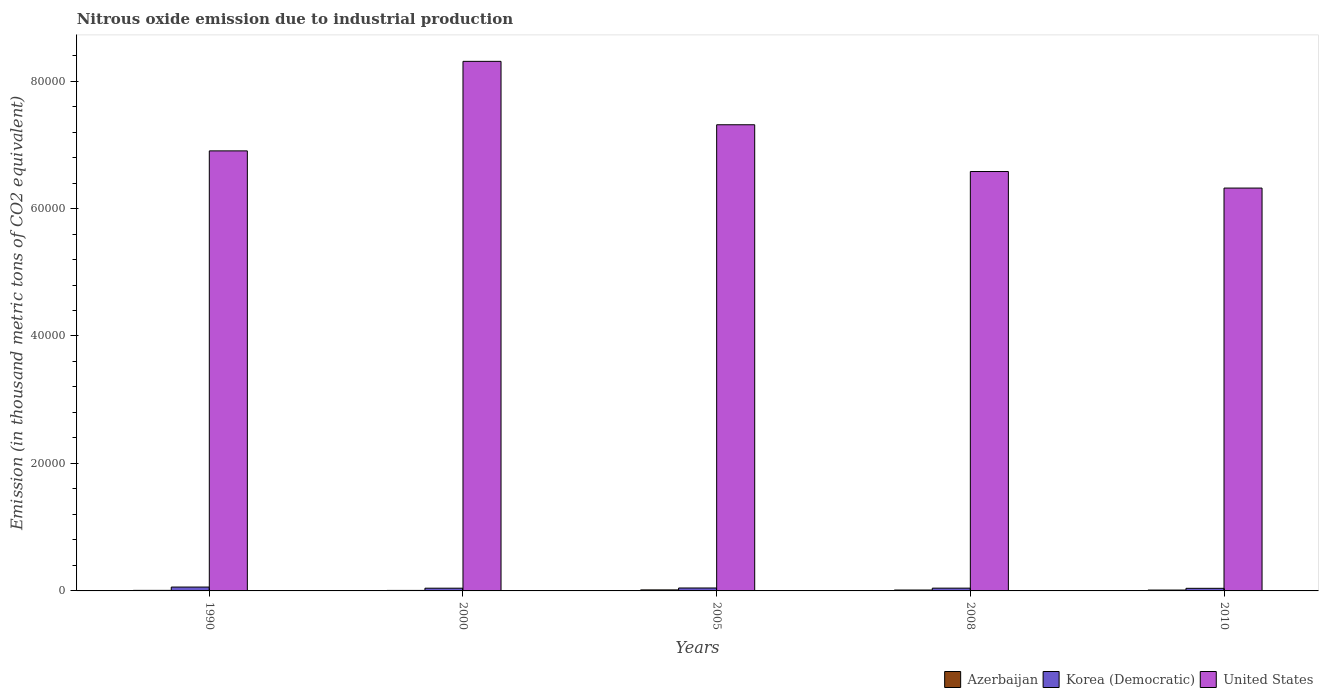How many different coloured bars are there?
Provide a succinct answer. 3. How many groups of bars are there?
Offer a terse response. 5. Are the number of bars per tick equal to the number of legend labels?
Your response must be concise. Yes. Are the number of bars on each tick of the X-axis equal?
Your response must be concise. Yes. How many bars are there on the 1st tick from the left?
Make the answer very short. 3. What is the label of the 3rd group of bars from the left?
Ensure brevity in your answer.  2005. In how many cases, is the number of bars for a given year not equal to the number of legend labels?
Give a very brief answer. 0. What is the amount of nitrous oxide emitted in Azerbaijan in 2000?
Keep it short and to the point. 79.5. Across all years, what is the maximum amount of nitrous oxide emitted in Azerbaijan?
Your answer should be very brief. 160.4. Across all years, what is the minimum amount of nitrous oxide emitted in Azerbaijan?
Offer a very short reply. 79.5. In which year was the amount of nitrous oxide emitted in Azerbaijan minimum?
Offer a terse response. 2000. What is the total amount of nitrous oxide emitted in Azerbaijan in the graph?
Keep it short and to the point. 604. What is the difference between the amount of nitrous oxide emitted in United States in 1990 and that in 2008?
Offer a very short reply. 3238.6. What is the difference between the amount of nitrous oxide emitted in Azerbaijan in 2000 and the amount of nitrous oxide emitted in Korea (Democratic) in 1990?
Provide a short and direct response. -526.1. What is the average amount of nitrous oxide emitted in Korea (Democratic) per year?
Provide a succinct answer. 467.46. In the year 2010, what is the difference between the amount of nitrous oxide emitted in Korea (Democratic) and amount of nitrous oxide emitted in Azerbaijan?
Give a very brief answer. 272.8. What is the ratio of the amount of nitrous oxide emitted in Azerbaijan in 2005 to that in 2008?
Your answer should be compact. 1.14. Is the amount of nitrous oxide emitted in United States in 1990 less than that in 2008?
Provide a succinct answer. No. Is the difference between the amount of nitrous oxide emitted in Korea (Democratic) in 2005 and 2010 greater than the difference between the amount of nitrous oxide emitted in Azerbaijan in 2005 and 2010?
Your response must be concise. Yes. What is the difference between the highest and the second highest amount of nitrous oxide emitted in United States?
Your answer should be compact. 9949.1. What is the difference between the highest and the lowest amount of nitrous oxide emitted in United States?
Provide a succinct answer. 1.99e+04. In how many years, is the amount of nitrous oxide emitted in Azerbaijan greater than the average amount of nitrous oxide emitted in Azerbaijan taken over all years?
Your response must be concise. 3. What does the 1st bar from the left in 2008 represents?
Your answer should be compact. Azerbaijan. What does the 3rd bar from the right in 1990 represents?
Keep it short and to the point. Azerbaijan. How many bars are there?
Your answer should be compact. 15. Are all the bars in the graph horizontal?
Provide a succinct answer. No. What is the difference between two consecutive major ticks on the Y-axis?
Give a very brief answer. 2.00e+04. Are the values on the major ticks of Y-axis written in scientific E-notation?
Provide a short and direct response. No. Does the graph contain grids?
Offer a terse response. No. Where does the legend appear in the graph?
Provide a succinct answer. Bottom right. How are the legend labels stacked?
Keep it short and to the point. Horizontal. What is the title of the graph?
Your answer should be very brief. Nitrous oxide emission due to industrial production. Does "Mauritania" appear as one of the legend labels in the graph?
Make the answer very short. No. What is the label or title of the Y-axis?
Your answer should be compact. Emission (in thousand metric tons of CO2 equivalent). What is the Emission (in thousand metric tons of CO2 equivalent) of Azerbaijan in 1990?
Ensure brevity in your answer.  87.4. What is the Emission (in thousand metric tons of CO2 equivalent) of Korea (Democratic) in 1990?
Provide a short and direct response. 605.6. What is the Emission (in thousand metric tons of CO2 equivalent) in United States in 1990?
Keep it short and to the point. 6.90e+04. What is the Emission (in thousand metric tons of CO2 equivalent) in Azerbaijan in 2000?
Provide a succinct answer. 79.5. What is the Emission (in thousand metric tons of CO2 equivalent) of Korea (Democratic) in 2000?
Make the answer very short. 427. What is the Emission (in thousand metric tons of CO2 equivalent) in United States in 2000?
Give a very brief answer. 8.31e+04. What is the Emission (in thousand metric tons of CO2 equivalent) of Azerbaijan in 2005?
Your answer should be very brief. 160.4. What is the Emission (in thousand metric tons of CO2 equivalent) in Korea (Democratic) in 2005?
Your answer should be very brief. 460.8. What is the Emission (in thousand metric tons of CO2 equivalent) of United States in 2005?
Offer a very short reply. 7.31e+04. What is the Emission (in thousand metric tons of CO2 equivalent) in Azerbaijan in 2008?
Your response must be concise. 141. What is the Emission (in thousand metric tons of CO2 equivalent) of Korea (Democratic) in 2008?
Make the answer very short. 435.4. What is the Emission (in thousand metric tons of CO2 equivalent) in United States in 2008?
Ensure brevity in your answer.  6.58e+04. What is the Emission (in thousand metric tons of CO2 equivalent) in Azerbaijan in 2010?
Your answer should be compact. 135.7. What is the Emission (in thousand metric tons of CO2 equivalent) of Korea (Democratic) in 2010?
Provide a short and direct response. 408.5. What is the Emission (in thousand metric tons of CO2 equivalent) of United States in 2010?
Offer a very short reply. 6.32e+04. Across all years, what is the maximum Emission (in thousand metric tons of CO2 equivalent) in Azerbaijan?
Provide a succinct answer. 160.4. Across all years, what is the maximum Emission (in thousand metric tons of CO2 equivalent) of Korea (Democratic)?
Provide a short and direct response. 605.6. Across all years, what is the maximum Emission (in thousand metric tons of CO2 equivalent) in United States?
Offer a terse response. 8.31e+04. Across all years, what is the minimum Emission (in thousand metric tons of CO2 equivalent) in Azerbaijan?
Offer a very short reply. 79.5. Across all years, what is the minimum Emission (in thousand metric tons of CO2 equivalent) in Korea (Democratic)?
Your response must be concise. 408.5. Across all years, what is the minimum Emission (in thousand metric tons of CO2 equivalent) of United States?
Offer a very short reply. 6.32e+04. What is the total Emission (in thousand metric tons of CO2 equivalent) in Azerbaijan in the graph?
Give a very brief answer. 604. What is the total Emission (in thousand metric tons of CO2 equivalent) of Korea (Democratic) in the graph?
Your response must be concise. 2337.3. What is the total Emission (in thousand metric tons of CO2 equivalent) in United States in the graph?
Your answer should be compact. 3.54e+05. What is the difference between the Emission (in thousand metric tons of CO2 equivalent) in Korea (Democratic) in 1990 and that in 2000?
Provide a succinct answer. 178.6. What is the difference between the Emission (in thousand metric tons of CO2 equivalent) in United States in 1990 and that in 2000?
Offer a very short reply. -1.40e+04. What is the difference between the Emission (in thousand metric tons of CO2 equivalent) in Azerbaijan in 1990 and that in 2005?
Your answer should be very brief. -73. What is the difference between the Emission (in thousand metric tons of CO2 equivalent) of Korea (Democratic) in 1990 and that in 2005?
Your answer should be very brief. 144.8. What is the difference between the Emission (in thousand metric tons of CO2 equivalent) in United States in 1990 and that in 2005?
Keep it short and to the point. -4098.5. What is the difference between the Emission (in thousand metric tons of CO2 equivalent) of Azerbaijan in 1990 and that in 2008?
Give a very brief answer. -53.6. What is the difference between the Emission (in thousand metric tons of CO2 equivalent) of Korea (Democratic) in 1990 and that in 2008?
Provide a succinct answer. 170.2. What is the difference between the Emission (in thousand metric tons of CO2 equivalent) in United States in 1990 and that in 2008?
Give a very brief answer. 3238.6. What is the difference between the Emission (in thousand metric tons of CO2 equivalent) in Azerbaijan in 1990 and that in 2010?
Your response must be concise. -48.3. What is the difference between the Emission (in thousand metric tons of CO2 equivalent) of Korea (Democratic) in 1990 and that in 2010?
Provide a succinct answer. 197.1. What is the difference between the Emission (in thousand metric tons of CO2 equivalent) of United States in 1990 and that in 2010?
Give a very brief answer. 5835.2. What is the difference between the Emission (in thousand metric tons of CO2 equivalent) of Azerbaijan in 2000 and that in 2005?
Keep it short and to the point. -80.9. What is the difference between the Emission (in thousand metric tons of CO2 equivalent) of Korea (Democratic) in 2000 and that in 2005?
Your answer should be compact. -33.8. What is the difference between the Emission (in thousand metric tons of CO2 equivalent) of United States in 2000 and that in 2005?
Your response must be concise. 9949.1. What is the difference between the Emission (in thousand metric tons of CO2 equivalent) in Azerbaijan in 2000 and that in 2008?
Make the answer very short. -61.5. What is the difference between the Emission (in thousand metric tons of CO2 equivalent) of Korea (Democratic) in 2000 and that in 2008?
Keep it short and to the point. -8.4. What is the difference between the Emission (in thousand metric tons of CO2 equivalent) in United States in 2000 and that in 2008?
Your answer should be very brief. 1.73e+04. What is the difference between the Emission (in thousand metric tons of CO2 equivalent) of Azerbaijan in 2000 and that in 2010?
Give a very brief answer. -56.2. What is the difference between the Emission (in thousand metric tons of CO2 equivalent) of Korea (Democratic) in 2000 and that in 2010?
Ensure brevity in your answer.  18.5. What is the difference between the Emission (in thousand metric tons of CO2 equivalent) of United States in 2000 and that in 2010?
Keep it short and to the point. 1.99e+04. What is the difference between the Emission (in thousand metric tons of CO2 equivalent) in Korea (Democratic) in 2005 and that in 2008?
Make the answer very short. 25.4. What is the difference between the Emission (in thousand metric tons of CO2 equivalent) in United States in 2005 and that in 2008?
Your answer should be compact. 7337.1. What is the difference between the Emission (in thousand metric tons of CO2 equivalent) of Azerbaijan in 2005 and that in 2010?
Provide a succinct answer. 24.7. What is the difference between the Emission (in thousand metric tons of CO2 equivalent) of Korea (Democratic) in 2005 and that in 2010?
Offer a terse response. 52.3. What is the difference between the Emission (in thousand metric tons of CO2 equivalent) in United States in 2005 and that in 2010?
Keep it short and to the point. 9933.7. What is the difference between the Emission (in thousand metric tons of CO2 equivalent) of Azerbaijan in 2008 and that in 2010?
Provide a short and direct response. 5.3. What is the difference between the Emission (in thousand metric tons of CO2 equivalent) in Korea (Democratic) in 2008 and that in 2010?
Provide a short and direct response. 26.9. What is the difference between the Emission (in thousand metric tons of CO2 equivalent) in United States in 2008 and that in 2010?
Keep it short and to the point. 2596.6. What is the difference between the Emission (in thousand metric tons of CO2 equivalent) of Azerbaijan in 1990 and the Emission (in thousand metric tons of CO2 equivalent) of Korea (Democratic) in 2000?
Offer a very short reply. -339.6. What is the difference between the Emission (in thousand metric tons of CO2 equivalent) of Azerbaijan in 1990 and the Emission (in thousand metric tons of CO2 equivalent) of United States in 2000?
Offer a very short reply. -8.30e+04. What is the difference between the Emission (in thousand metric tons of CO2 equivalent) in Korea (Democratic) in 1990 and the Emission (in thousand metric tons of CO2 equivalent) in United States in 2000?
Ensure brevity in your answer.  -8.25e+04. What is the difference between the Emission (in thousand metric tons of CO2 equivalent) in Azerbaijan in 1990 and the Emission (in thousand metric tons of CO2 equivalent) in Korea (Democratic) in 2005?
Offer a terse response. -373.4. What is the difference between the Emission (in thousand metric tons of CO2 equivalent) of Azerbaijan in 1990 and the Emission (in thousand metric tons of CO2 equivalent) of United States in 2005?
Your response must be concise. -7.31e+04. What is the difference between the Emission (in thousand metric tons of CO2 equivalent) of Korea (Democratic) in 1990 and the Emission (in thousand metric tons of CO2 equivalent) of United States in 2005?
Ensure brevity in your answer.  -7.25e+04. What is the difference between the Emission (in thousand metric tons of CO2 equivalent) of Azerbaijan in 1990 and the Emission (in thousand metric tons of CO2 equivalent) of Korea (Democratic) in 2008?
Provide a short and direct response. -348. What is the difference between the Emission (in thousand metric tons of CO2 equivalent) of Azerbaijan in 1990 and the Emission (in thousand metric tons of CO2 equivalent) of United States in 2008?
Make the answer very short. -6.57e+04. What is the difference between the Emission (in thousand metric tons of CO2 equivalent) in Korea (Democratic) in 1990 and the Emission (in thousand metric tons of CO2 equivalent) in United States in 2008?
Make the answer very short. -6.52e+04. What is the difference between the Emission (in thousand metric tons of CO2 equivalent) in Azerbaijan in 1990 and the Emission (in thousand metric tons of CO2 equivalent) in Korea (Democratic) in 2010?
Offer a very short reply. -321.1. What is the difference between the Emission (in thousand metric tons of CO2 equivalent) of Azerbaijan in 1990 and the Emission (in thousand metric tons of CO2 equivalent) of United States in 2010?
Offer a very short reply. -6.31e+04. What is the difference between the Emission (in thousand metric tons of CO2 equivalent) in Korea (Democratic) in 1990 and the Emission (in thousand metric tons of CO2 equivalent) in United States in 2010?
Your answer should be very brief. -6.26e+04. What is the difference between the Emission (in thousand metric tons of CO2 equivalent) in Azerbaijan in 2000 and the Emission (in thousand metric tons of CO2 equivalent) in Korea (Democratic) in 2005?
Make the answer very short. -381.3. What is the difference between the Emission (in thousand metric tons of CO2 equivalent) in Azerbaijan in 2000 and the Emission (in thousand metric tons of CO2 equivalent) in United States in 2005?
Keep it short and to the point. -7.31e+04. What is the difference between the Emission (in thousand metric tons of CO2 equivalent) in Korea (Democratic) in 2000 and the Emission (in thousand metric tons of CO2 equivalent) in United States in 2005?
Provide a short and direct response. -7.27e+04. What is the difference between the Emission (in thousand metric tons of CO2 equivalent) in Azerbaijan in 2000 and the Emission (in thousand metric tons of CO2 equivalent) in Korea (Democratic) in 2008?
Give a very brief answer. -355.9. What is the difference between the Emission (in thousand metric tons of CO2 equivalent) in Azerbaijan in 2000 and the Emission (in thousand metric tons of CO2 equivalent) in United States in 2008?
Provide a succinct answer. -6.57e+04. What is the difference between the Emission (in thousand metric tons of CO2 equivalent) of Korea (Democratic) in 2000 and the Emission (in thousand metric tons of CO2 equivalent) of United States in 2008?
Provide a succinct answer. -6.54e+04. What is the difference between the Emission (in thousand metric tons of CO2 equivalent) in Azerbaijan in 2000 and the Emission (in thousand metric tons of CO2 equivalent) in Korea (Democratic) in 2010?
Your response must be concise. -329. What is the difference between the Emission (in thousand metric tons of CO2 equivalent) of Azerbaijan in 2000 and the Emission (in thousand metric tons of CO2 equivalent) of United States in 2010?
Your answer should be compact. -6.31e+04. What is the difference between the Emission (in thousand metric tons of CO2 equivalent) of Korea (Democratic) in 2000 and the Emission (in thousand metric tons of CO2 equivalent) of United States in 2010?
Give a very brief answer. -6.28e+04. What is the difference between the Emission (in thousand metric tons of CO2 equivalent) of Azerbaijan in 2005 and the Emission (in thousand metric tons of CO2 equivalent) of Korea (Democratic) in 2008?
Ensure brevity in your answer.  -275. What is the difference between the Emission (in thousand metric tons of CO2 equivalent) in Azerbaijan in 2005 and the Emission (in thousand metric tons of CO2 equivalent) in United States in 2008?
Offer a terse response. -6.56e+04. What is the difference between the Emission (in thousand metric tons of CO2 equivalent) of Korea (Democratic) in 2005 and the Emission (in thousand metric tons of CO2 equivalent) of United States in 2008?
Ensure brevity in your answer.  -6.53e+04. What is the difference between the Emission (in thousand metric tons of CO2 equivalent) in Azerbaijan in 2005 and the Emission (in thousand metric tons of CO2 equivalent) in Korea (Democratic) in 2010?
Offer a very short reply. -248.1. What is the difference between the Emission (in thousand metric tons of CO2 equivalent) of Azerbaijan in 2005 and the Emission (in thousand metric tons of CO2 equivalent) of United States in 2010?
Give a very brief answer. -6.30e+04. What is the difference between the Emission (in thousand metric tons of CO2 equivalent) of Korea (Democratic) in 2005 and the Emission (in thousand metric tons of CO2 equivalent) of United States in 2010?
Your response must be concise. -6.27e+04. What is the difference between the Emission (in thousand metric tons of CO2 equivalent) in Azerbaijan in 2008 and the Emission (in thousand metric tons of CO2 equivalent) in Korea (Democratic) in 2010?
Offer a very short reply. -267.5. What is the difference between the Emission (in thousand metric tons of CO2 equivalent) of Azerbaijan in 2008 and the Emission (in thousand metric tons of CO2 equivalent) of United States in 2010?
Your answer should be very brief. -6.31e+04. What is the difference between the Emission (in thousand metric tons of CO2 equivalent) of Korea (Democratic) in 2008 and the Emission (in thousand metric tons of CO2 equivalent) of United States in 2010?
Give a very brief answer. -6.28e+04. What is the average Emission (in thousand metric tons of CO2 equivalent) in Azerbaijan per year?
Keep it short and to the point. 120.8. What is the average Emission (in thousand metric tons of CO2 equivalent) of Korea (Democratic) per year?
Make the answer very short. 467.46. What is the average Emission (in thousand metric tons of CO2 equivalent) in United States per year?
Provide a succinct answer. 7.09e+04. In the year 1990, what is the difference between the Emission (in thousand metric tons of CO2 equivalent) in Azerbaijan and Emission (in thousand metric tons of CO2 equivalent) in Korea (Democratic)?
Provide a short and direct response. -518.2. In the year 1990, what is the difference between the Emission (in thousand metric tons of CO2 equivalent) in Azerbaijan and Emission (in thousand metric tons of CO2 equivalent) in United States?
Your answer should be very brief. -6.90e+04. In the year 1990, what is the difference between the Emission (in thousand metric tons of CO2 equivalent) in Korea (Democratic) and Emission (in thousand metric tons of CO2 equivalent) in United States?
Provide a succinct answer. -6.84e+04. In the year 2000, what is the difference between the Emission (in thousand metric tons of CO2 equivalent) of Azerbaijan and Emission (in thousand metric tons of CO2 equivalent) of Korea (Democratic)?
Provide a short and direct response. -347.5. In the year 2000, what is the difference between the Emission (in thousand metric tons of CO2 equivalent) of Azerbaijan and Emission (in thousand metric tons of CO2 equivalent) of United States?
Ensure brevity in your answer.  -8.30e+04. In the year 2000, what is the difference between the Emission (in thousand metric tons of CO2 equivalent) in Korea (Democratic) and Emission (in thousand metric tons of CO2 equivalent) in United States?
Provide a short and direct response. -8.27e+04. In the year 2005, what is the difference between the Emission (in thousand metric tons of CO2 equivalent) in Azerbaijan and Emission (in thousand metric tons of CO2 equivalent) in Korea (Democratic)?
Make the answer very short. -300.4. In the year 2005, what is the difference between the Emission (in thousand metric tons of CO2 equivalent) of Azerbaijan and Emission (in thousand metric tons of CO2 equivalent) of United States?
Your response must be concise. -7.30e+04. In the year 2005, what is the difference between the Emission (in thousand metric tons of CO2 equivalent) in Korea (Democratic) and Emission (in thousand metric tons of CO2 equivalent) in United States?
Offer a terse response. -7.27e+04. In the year 2008, what is the difference between the Emission (in thousand metric tons of CO2 equivalent) in Azerbaijan and Emission (in thousand metric tons of CO2 equivalent) in Korea (Democratic)?
Provide a succinct answer. -294.4. In the year 2008, what is the difference between the Emission (in thousand metric tons of CO2 equivalent) in Azerbaijan and Emission (in thousand metric tons of CO2 equivalent) in United States?
Give a very brief answer. -6.57e+04. In the year 2008, what is the difference between the Emission (in thousand metric tons of CO2 equivalent) in Korea (Democratic) and Emission (in thousand metric tons of CO2 equivalent) in United States?
Give a very brief answer. -6.54e+04. In the year 2010, what is the difference between the Emission (in thousand metric tons of CO2 equivalent) in Azerbaijan and Emission (in thousand metric tons of CO2 equivalent) in Korea (Democratic)?
Give a very brief answer. -272.8. In the year 2010, what is the difference between the Emission (in thousand metric tons of CO2 equivalent) of Azerbaijan and Emission (in thousand metric tons of CO2 equivalent) of United States?
Offer a very short reply. -6.31e+04. In the year 2010, what is the difference between the Emission (in thousand metric tons of CO2 equivalent) in Korea (Democratic) and Emission (in thousand metric tons of CO2 equivalent) in United States?
Provide a succinct answer. -6.28e+04. What is the ratio of the Emission (in thousand metric tons of CO2 equivalent) in Azerbaijan in 1990 to that in 2000?
Your answer should be compact. 1.1. What is the ratio of the Emission (in thousand metric tons of CO2 equivalent) in Korea (Democratic) in 1990 to that in 2000?
Make the answer very short. 1.42. What is the ratio of the Emission (in thousand metric tons of CO2 equivalent) of United States in 1990 to that in 2000?
Offer a very short reply. 0.83. What is the ratio of the Emission (in thousand metric tons of CO2 equivalent) of Azerbaijan in 1990 to that in 2005?
Your answer should be compact. 0.54. What is the ratio of the Emission (in thousand metric tons of CO2 equivalent) of Korea (Democratic) in 1990 to that in 2005?
Your response must be concise. 1.31. What is the ratio of the Emission (in thousand metric tons of CO2 equivalent) in United States in 1990 to that in 2005?
Make the answer very short. 0.94. What is the ratio of the Emission (in thousand metric tons of CO2 equivalent) of Azerbaijan in 1990 to that in 2008?
Your answer should be compact. 0.62. What is the ratio of the Emission (in thousand metric tons of CO2 equivalent) of Korea (Democratic) in 1990 to that in 2008?
Offer a terse response. 1.39. What is the ratio of the Emission (in thousand metric tons of CO2 equivalent) in United States in 1990 to that in 2008?
Your answer should be very brief. 1.05. What is the ratio of the Emission (in thousand metric tons of CO2 equivalent) in Azerbaijan in 1990 to that in 2010?
Offer a very short reply. 0.64. What is the ratio of the Emission (in thousand metric tons of CO2 equivalent) of Korea (Democratic) in 1990 to that in 2010?
Your response must be concise. 1.48. What is the ratio of the Emission (in thousand metric tons of CO2 equivalent) of United States in 1990 to that in 2010?
Keep it short and to the point. 1.09. What is the ratio of the Emission (in thousand metric tons of CO2 equivalent) of Azerbaijan in 2000 to that in 2005?
Your answer should be compact. 0.5. What is the ratio of the Emission (in thousand metric tons of CO2 equivalent) in Korea (Democratic) in 2000 to that in 2005?
Offer a terse response. 0.93. What is the ratio of the Emission (in thousand metric tons of CO2 equivalent) of United States in 2000 to that in 2005?
Give a very brief answer. 1.14. What is the ratio of the Emission (in thousand metric tons of CO2 equivalent) in Azerbaijan in 2000 to that in 2008?
Make the answer very short. 0.56. What is the ratio of the Emission (in thousand metric tons of CO2 equivalent) in Korea (Democratic) in 2000 to that in 2008?
Provide a succinct answer. 0.98. What is the ratio of the Emission (in thousand metric tons of CO2 equivalent) of United States in 2000 to that in 2008?
Make the answer very short. 1.26. What is the ratio of the Emission (in thousand metric tons of CO2 equivalent) of Azerbaijan in 2000 to that in 2010?
Your response must be concise. 0.59. What is the ratio of the Emission (in thousand metric tons of CO2 equivalent) of Korea (Democratic) in 2000 to that in 2010?
Your answer should be very brief. 1.05. What is the ratio of the Emission (in thousand metric tons of CO2 equivalent) in United States in 2000 to that in 2010?
Provide a short and direct response. 1.31. What is the ratio of the Emission (in thousand metric tons of CO2 equivalent) in Azerbaijan in 2005 to that in 2008?
Ensure brevity in your answer.  1.14. What is the ratio of the Emission (in thousand metric tons of CO2 equivalent) of Korea (Democratic) in 2005 to that in 2008?
Ensure brevity in your answer.  1.06. What is the ratio of the Emission (in thousand metric tons of CO2 equivalent) of United States in 2005 to that in 2008?
Your response must be concise. 1.11. What is the ratio of the Emission (in thousand metric tons of CO2 equivalent) of Azerbaijan in 2005 to that in 2010?
Your response must be concise. 1.18. What is the ratio of the Emission (in thousand metric tons of CO2 equivalent) in Korea (Democratic) in 2005 to that in 2010?
Ensure brevity in your answer.  1.13. What is the ratio of the Emission (in thousand metric tons of CO2 equivalent) of United States in 2005 to that in 2010?
Provide a succinct answer. 1.16. What is the ratio of the Emission (in thousand metric tons of CO2 equivalent) of Azerbaijan in 2008 to that in 2010?
Offer a terse response. 1.04. What is the ratio of the Emission (in thousand metric tons of CO2 equivalent) of Korea (Democratic) in 2008 to that in 2010?
Ensure brevity in your answer.  1.07. What is the ratio of the Emission (in thousand metric tons of CO2 equivalent) of United States in 2008 to that in 2010?
Ensure brevity in your answer.  1.04. What is the difference between the highest and the second highest Emission (in thousand metric tons of CO2 equivalent) in Korea (Democratic)?
Provide a short and direct response. 144.8. What is the difference between the highest and the second highest Emission (in thousand metric tons of CO2 equivalent) in United States?
Offer a terse response. 9949.1. What is the difference between the highest and the lowest Emission (in thousand metric tons of CO2 equivalent) in Azerbaijan?
Provide a short and direct response. 80.9. What is the difference between the highest and the lowest Emission (in thousand metric tons of CO2 equivalent) in Korea (Democratic)?
Your answer should be compact. 197.1. What is the difference between the highest and the lowest Emission (in thousand metric tons of CO2 equivalent) of United States?
Your answer should be very brief. 1.99e+04. 